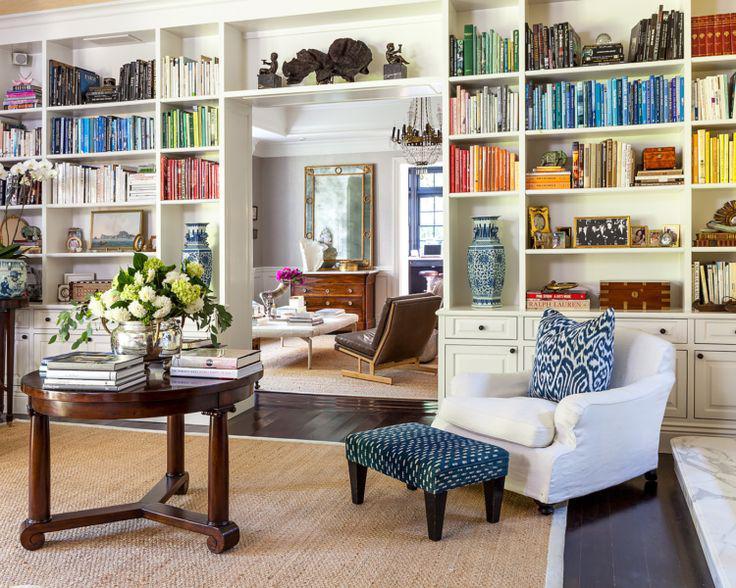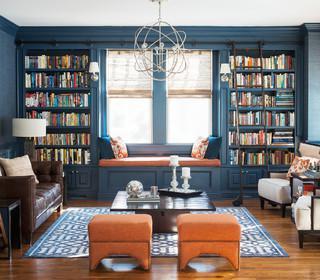The first image is the image on the left, the second image is the image on the right. For the images displayed, is the sentence "In one image, a seating area is in front of an interior doorway that is surrounded by bookcases." factually correct? Answer yes or no. Yes. 